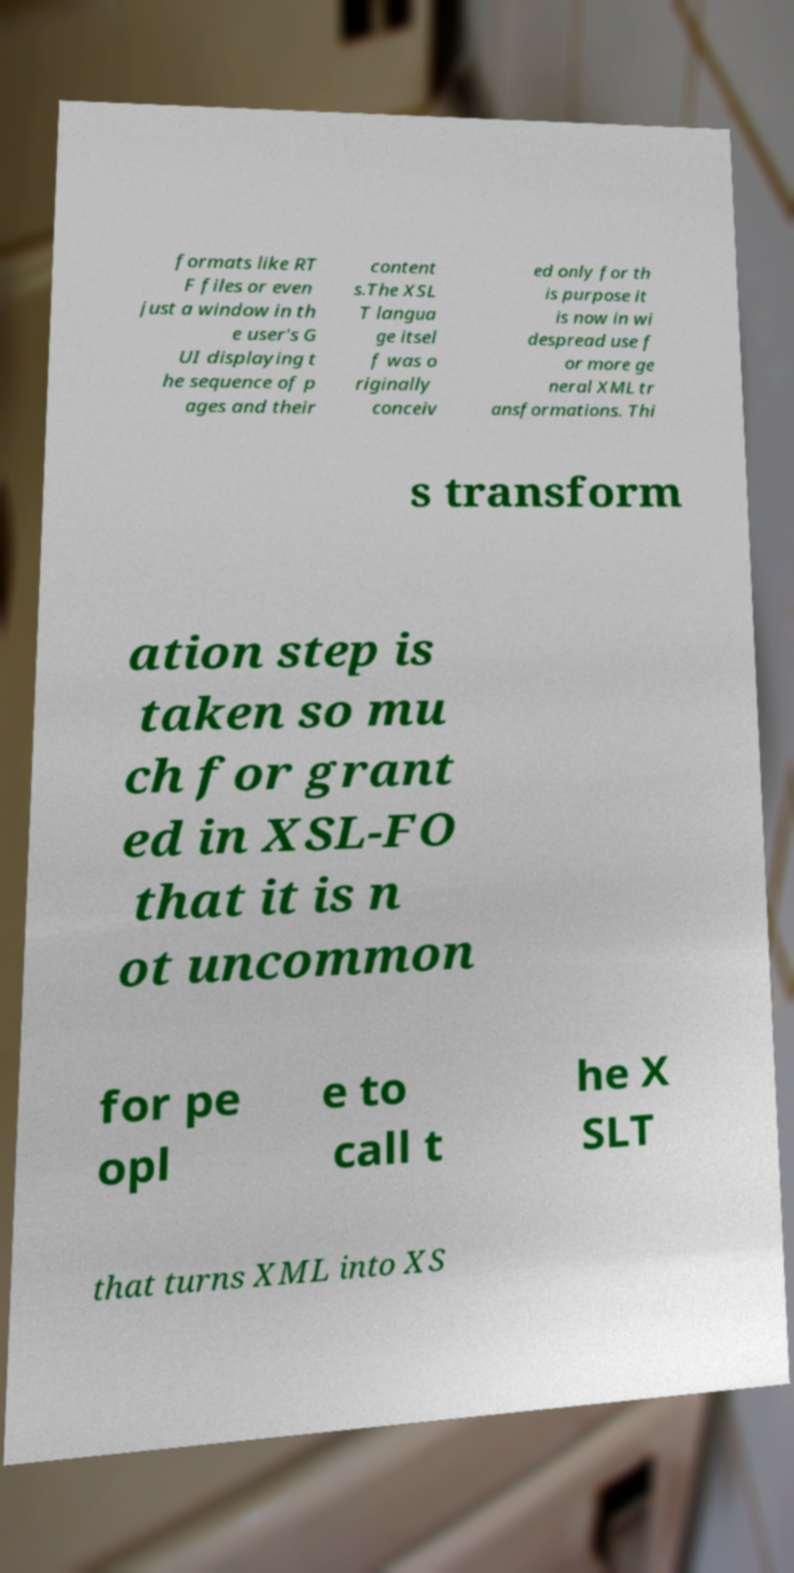Please identify and transcribe the text found in this image. formats like RT F files or even just a window in th e user's G UI displaying t he sequence of p ages and their content s.The XSL T langua ge itsel f was o riginally conceiv ed only for th is purpose it is now in wi despread use f or more ge neral XML tr ansformations. Thi s transform ation step is taken so mu ch for grant ed in XSL-FO that it is n ot uncommon for pe opl e to call t he X SLT that turns XML into XS 